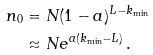<formula> <loc_0><loc_0><loc_500><loc_500>n _ { 0 } & = N ( 1 - a ) ^ { L - k _ { \min } } \\ & \approx N e ^ { a ( k _ { \min } - L ) } \, .</formula> 